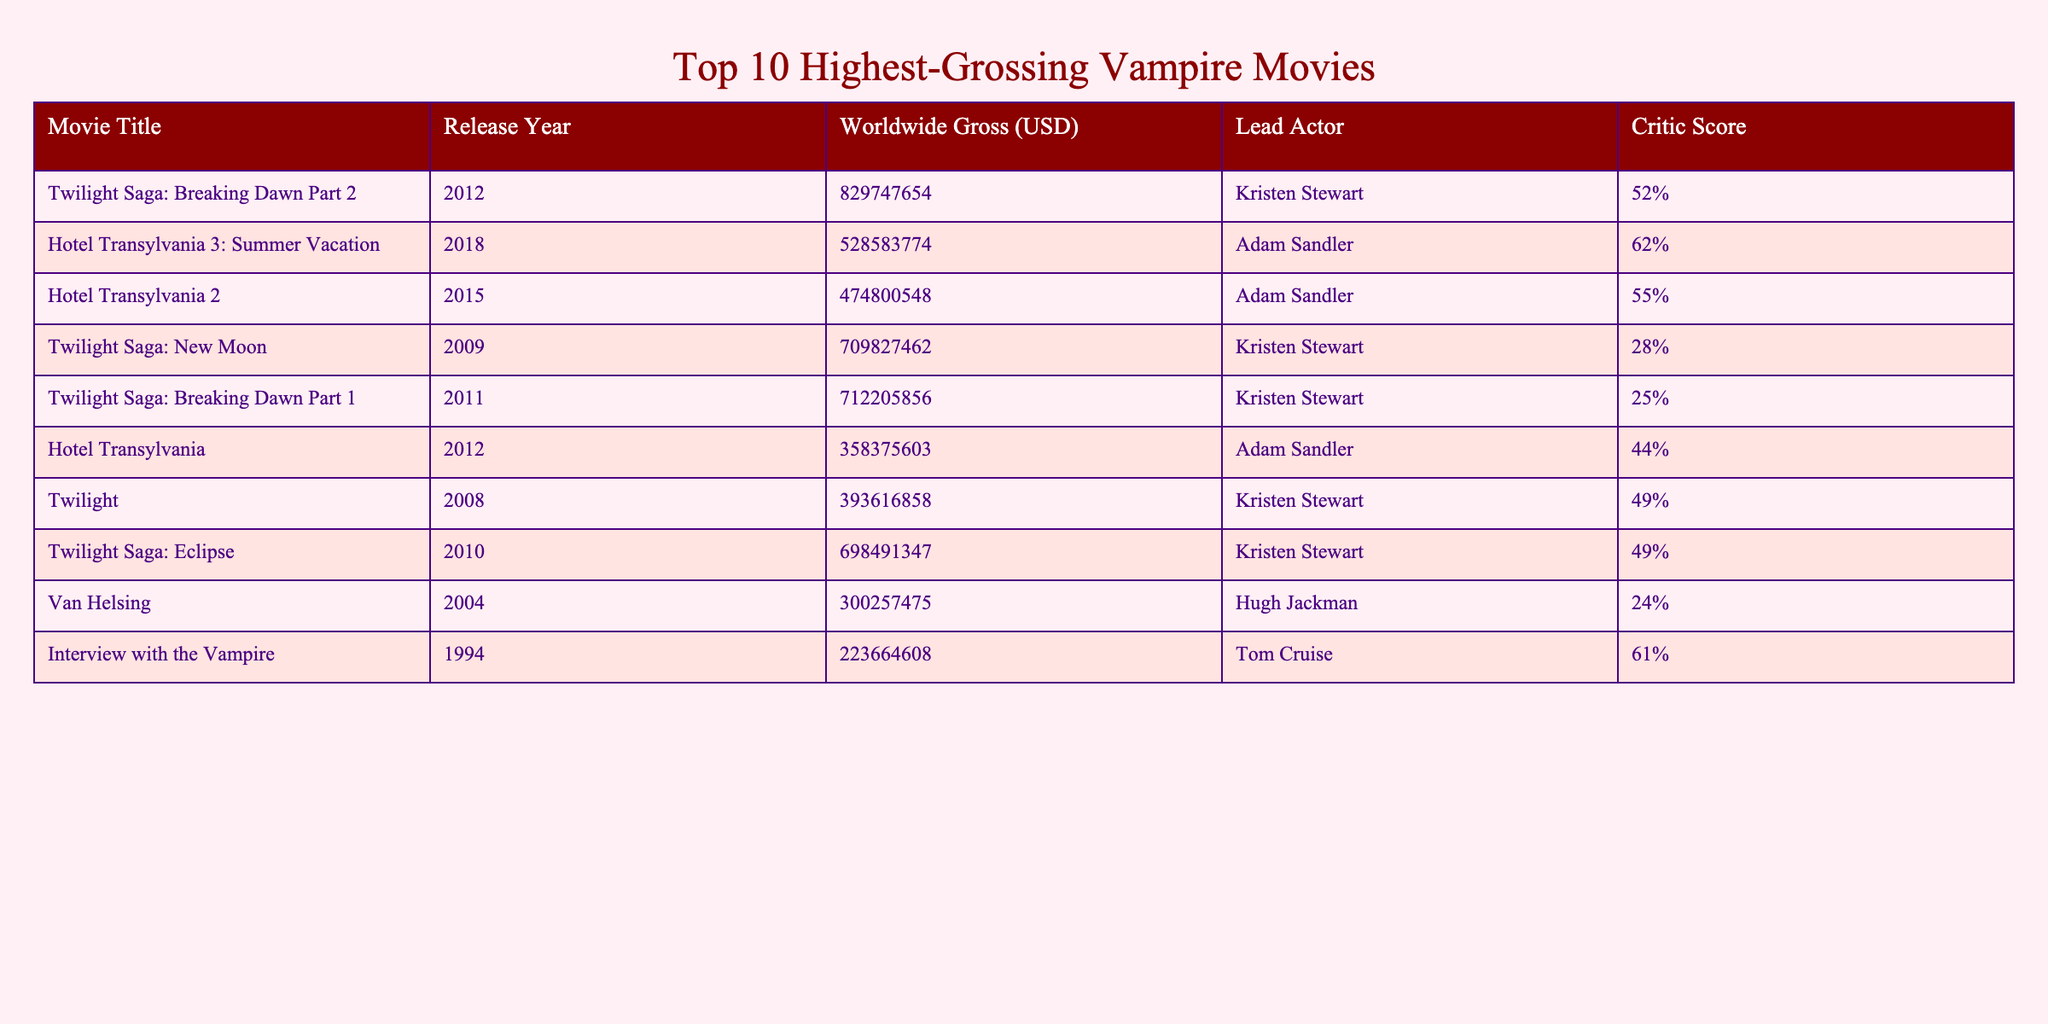What is the highest-grossing vampire movie of all time? The table shows the "Worldwide Gross (USD)" for each movie, and the movie with the highest value is "Twilight Saga: Breaking Dawn Part 2" with 829,747,654 USD.
Answer: Twilight Saga: Breaking Dawn Part 2 Which movie features Adam Sandler as the lead actor? Adam Sandler is listed as the lead actor in three movies: "Hotel Transylvania 3: Summer Vacation," "Hotel Transylvania 2," and "Hotel Transylvania."
Answer: Hotel Transylvania 3: Summer Vacation, Hotel Transylvania 2, Hotel Transylvania What is the average critic score of the "Twilight" movie series? The critic scores for the "Twilight" series are: Breaking Dawn Part 2 (52%), New Moon (28%), Breaking Dawn Part 1 (25%), Twilight (49%), and Eclipse (49%). Summing them gives 52 + 28 + 25 + 49 + 49 = 203. There are 5 movies, so the average is 203 / 5 = 40.6%.
Answer: 40.6% Is "Interview with the Vampire" among the top 10 highest-grossing vampire movies? "Interview with the Vampire" is included in the table, confirming that it is indeed one of the top 10 highest-grossing vampire movies.
Answer: Yes Which movie had the lowest worldwide gross, and what was the amount? By checking the "Worldwide Gross (USD)" column for the lowest value, we find that "Van Helsing" has the lowest gross of 300,257,475 USD.
Answer: Van Helsing, 300257475 USD What is the total worldwide gross of all listed "Hotel Transylvania" movies? The "Hotel Transylvania" movies listed are: "Hotel Transylvania 3: Summer Vacation" (528,583,774), "Hotel Transylvania 2" (474,800,548), and "Hotel Transylvania" (358,375,603). Adding these values gives 528,583,774 + 474,800,548 + 358,375,603 = 1,361,759,925 USD.
Answer: 1,361,759,925 USD Which lead actor has the highest average critic score from their movies listed? Kristen Stewart appears in five movies: Breaking Dawn Part 2 (52%), New Moon (28%), Breaking Dawn Part 1 (25%), Twilight (49%), and Eclipse (49%). The average is 40.6%. Adam Sandler appears in three movies: Hotel Transylvania 3: Summer Vacation (62%), Hotel Transylvania 2 (55%), and Hotel Transylvania (44%), with an average of 53.67%. Adam Sandler has a higher average critic score.
Answer: Adam Sandler How many movies featuring Kristen Stewart grossed over 700 million USD? The movies featuring Kristen Stewart that grossed over 700 million USD are: "Twilight Saga: Breaking Dawn Part 2" (829,747,654) and "Twilight Saga: New Moon" (709,827,462). Thus, there are two such movies.
Answer: 2 